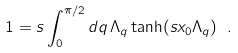Convert formula to latex. <formula><loc_0><loc_0><loc_500><loc_500>1 = s \int ^ { \pi / 2 } _ { 0 } d q \, \Lambda _ { q } \tanh ( s x _ { 0 } \Lambda _ { q } ) \ .</formula> 